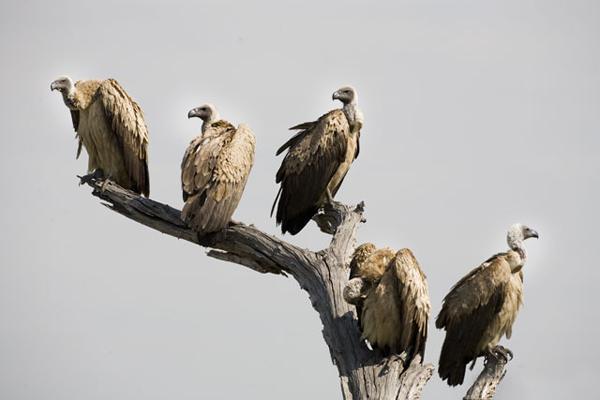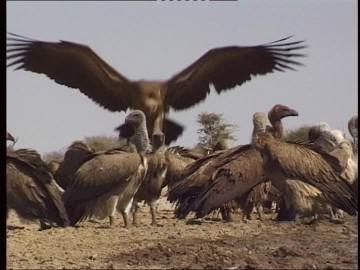The first image is the image on the left, the second image is the image on the right. Considering the images on both sides, is "There are no more than five birds in one of the images." valid? Answer yes or no. Yes. 